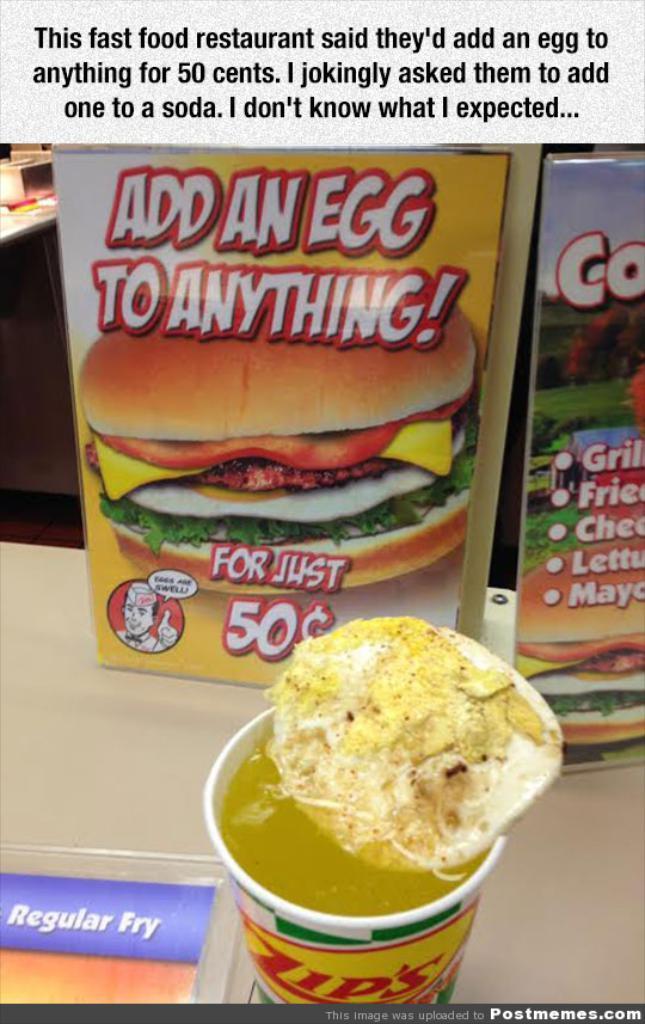In one or two sentences, can you explain what this image depicts? We can see cup with drink and food,posters and objects on the table. In the background we can see objects on the table. At the top we can see some information. In the bottom right side of the image we can see water mark. 